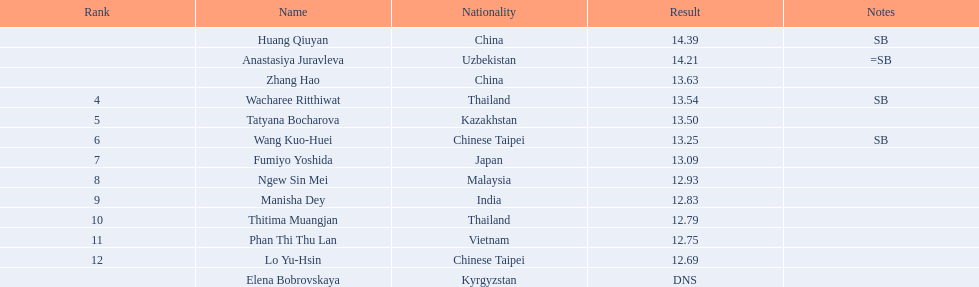How many athletes had a better result than tatyana bocharova? 4. 